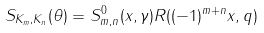Convert formula to latex. <formula><loc_0><loc_0><loc_500><loc_500>S _ { K _ { m } , K _ { n } } ( \theta ) = S _ { m , n } ^ { 0 } ( x , \gamma ) R ( ( - 1 ) ^ { m + n } x , q )</formula> 